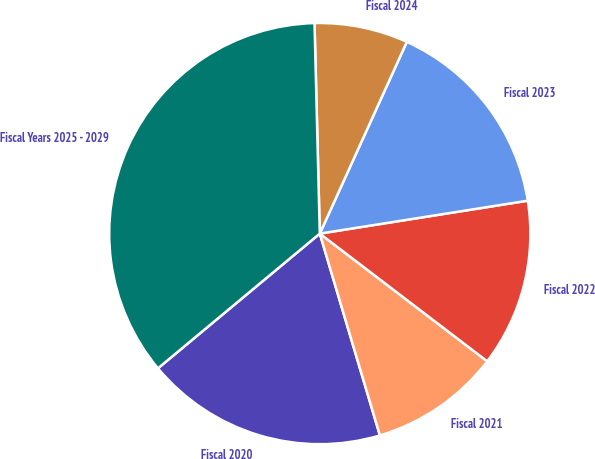<chart> <loc_0><loc_0><loc_500><loc_500><pie_chart><fcel>Fiscal 2020<fcel>Fiscal 2021<fcel>Fiscal 2022<fcel>Fiscal 2023<fcel>Fiscal 2024<fcel>Fiscal Years 2025 - 2029<nl><fcel>18.56%<fcel>10.02%<fcel>12.87%<fcel>15.72%<fcel>7.18%<fcel>35.65%<nl></chart> 